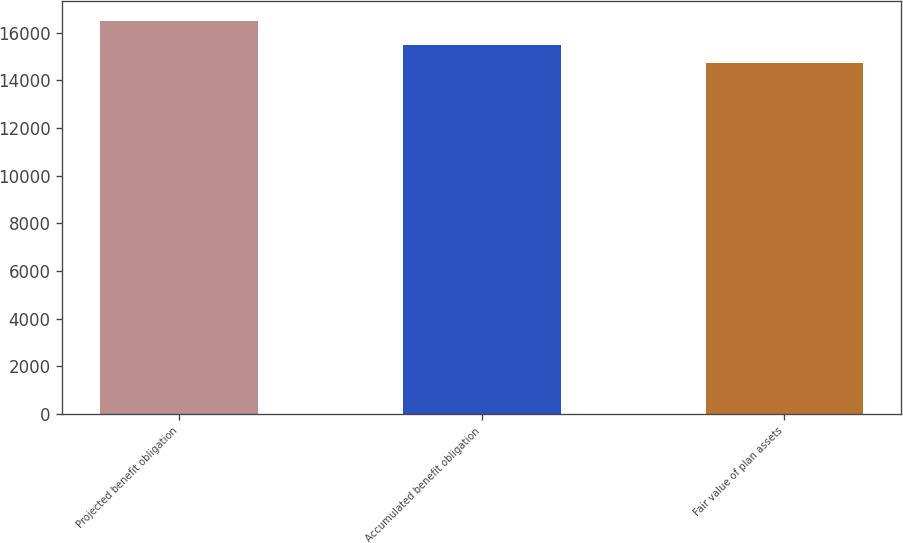<chart> <loc_0><loc_0><loc_500><loc_500><bar_chart><fcel>Projected benefit obligation<fcel>Accumulated benefit obligation<fcel>Fair value of plan assets<nl><fcel>16492<fcel>15496<fcel>14703<nl></chart> 